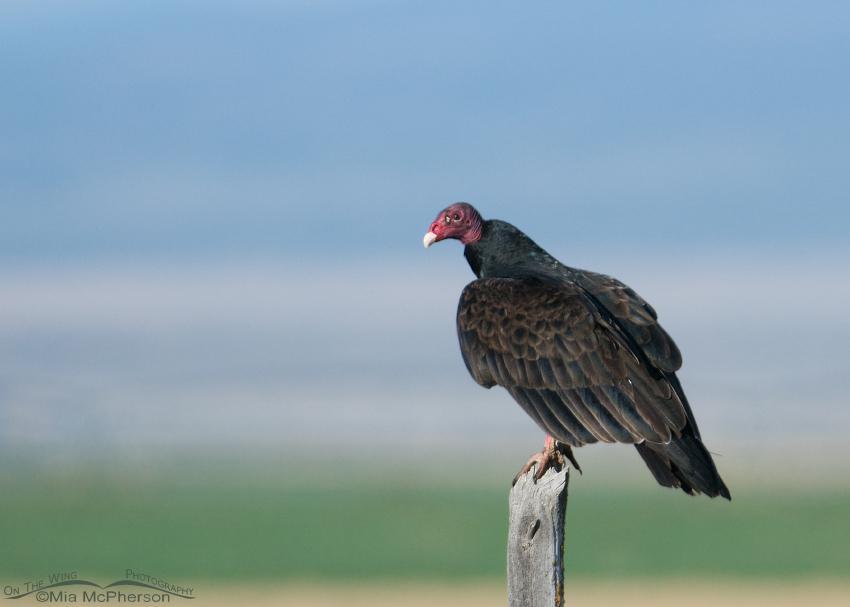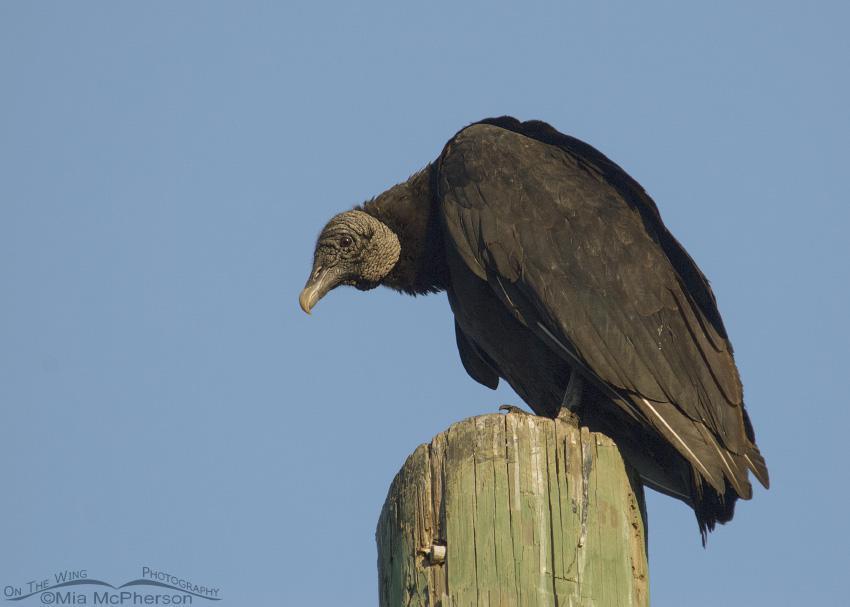The first image is the image on the left, the second image is the image on the right. Examine the images to the left and right. Is the description "There is at least one vulture with a gray head and black feathers perched upon a piece of wood." accurate? Answer yes or no. Yes. The first image is the image on the left, the second image is the image on the right. Considering the images on both sides, is "The bird on the left is flying in the air." valid? Answer yes or no. No. 